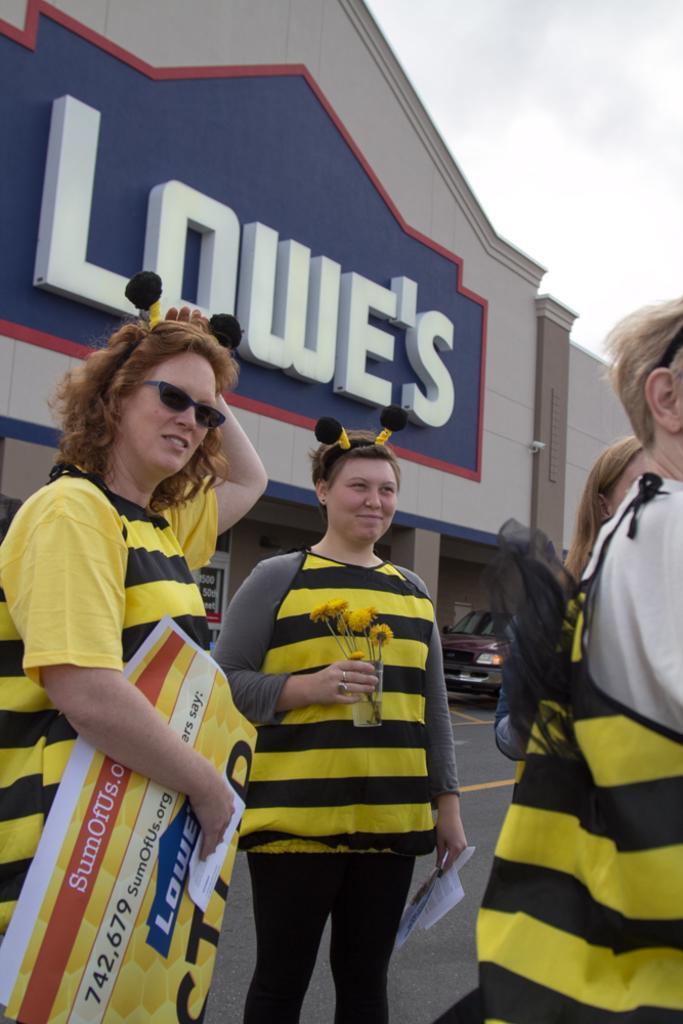Please provide a concise description of this image. In this image we can see three women are standing and they are wearing yellow and black color tops. One woman is holding banner in her hand and the other one is holding flowers in her hand. Background of the image one building is there. In front of the building car is present. The sky is full of clouds. 